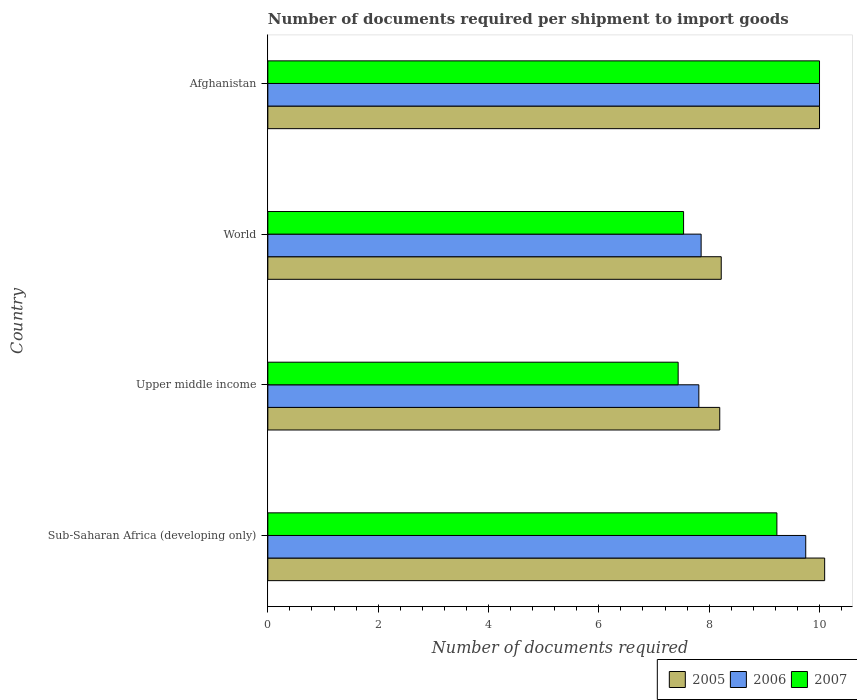Are the number of bars per tick equal to the number of legend labels?
Offer a terse response. Yes. Are the number of bars on each tick of the Y-axis equal?
Provide a short and direct response. Yes. How many bars are there on the 1st tick from the bottom?
Give a very brief answer. 3. What is the label of the 2nd group of bars from the top?
Keep it short and to the point. World. What is the number of documents required per shipment to import goods in 2007 in World?
Keep it short and to the point. 7.54. Across all countries, what is the maximum number of documents required per shipment to import goods in 2006?
Offer a very short reply. 10. Across all countries, what is the minimum number of documents required per shipment to import goods in 2006?
Provide a short and direct response. 7.81. In which country was the number of documents required per shipment to import goods in 2007 maximum?
Your response must be concise. Afghanistan. In which country was the number of documents required per shipment to import goods in 2005 minimum?
Make the answer very short. Upper middle income. What is the total number of documents required per shipment to import goods in 2007 in the graph?
Offer a very short reply. 34.2. What is the difference between the number of documents required per shipment to import goods in 2005 in Upper middle income and that in World?
Ensure brevity in your answer.  -0.03. What is the difference between the number of documents required per shipment to import goods in 2005 in Upper middle income and the number of documents required per shipment to import goods in 2007 in Afghanistan?
Keep it short and to the point. -1.81. What is the average number of documents required per shipment to import goods in 2006 per country?
Ensure brevity in your answer.  8.85. What is the difference between the number of documents required per shipment to import goods in 2007 and number of documents required per shipment to import goods in 2005 in Sub-Saharan Africa (developing only)?
Give a very brief answer. -0.87. What is the ratio of the number of documents required per shipment to import goods in 2007 in Sub-Saharan Africa (developing only) to that in World?
Your response must be concise. 1.22. What is the difference between the highest and the lowest number of documents required per shipment to import goods in 2006?
Offer a terse response. 2.19. What does the 1st bar from the bottom in Afghanistan represents?
Give a very brief answer. 2005. Is it the case that in every country, the sum of the number of documents required per shipment to import goods in 2005 and number of documents required per shipment to import goods in 2007 is greater than the number of documents required per shipment to import goods in 2006?
Offer a very short reply. Yes. How many bars are there?
Provide a succinct answer. 12. What is the difference between two consecutive major ticks on the X-axis?
Make the answer very short. 2. Are the values on the major ticks of X-axis written in scientific E-notation?
Offer a terse response. No. Does the graph contain any zero values?
Offer a very short reply. No. Where does the legend appear in the graph?
Keep it short and to the point. Bottom right. How many legend labels are there?
Offer a very short reply. 3. How are the legend labels stacked?
Offer a terse response. Horizontal. What is the title of the graph?
Keep it short and to the point. Number of documents required per shipment to import goods. Does "1963" appear as one of the legend labels in the graph?
Your answer should be compact. No. What is the label or title of the X-axis?
Give a very brief answer. Number of documents required. What is the label or title of the Y-axis?
Your response must be concise. Country. What is the Number of documents required of 2005 in Sub-Saharan Africa (developing only)?
Ensure brevity in your answer.  10.09. What is the Number of documents required in 2006 in Sub-Saharan Africa (developing only)?
Your answer should be very brief. 9.75. What is the Number of documents required in 2007 in Sub-Saharan Africa (developing only)?
Make the answer very short. 9.23. What is the Number of documents required in 2005 in Upper middle income?
Your answer should be compact. 8.19. What is the Number of documents required in 2006 in Upper middle income?
Offer a very short reply. 7.81. What is the Number of documents required of 2007 in Upper middle income?
Give a very brief answer. 7.44. What is the Number of documents required in 2005 in World?
Keep it short and to the point. 8.22. What is the Number of documents required in 2006 in World?
Give a very brief answer. 7.85. What is the Number of documents required of 2007 in World?
Ensure brevity in your answer.  7.54. What is the Number of documents required in 2005 in Afghanistan?
Your response must be concise. 10. What is the Number of documents required of 2007 in Afghanistan?
Give a very brief answer. 10. Across all countries, what is the maximum Number of documents required in 2005?
Your answer should be very brief. 10.09. Across all countries, what is the minimum Number of documents required in 2005?
Make the answer very short. 8.19. Across all countries, what is the minimum Number of documents required in 2006?
Give a very brief answer. 7.81. Across all countries, what is the minimum Number of documents required in 2007?
Give a very brief answer. 7.44. What is the total Number of documents required in 2005 in the graph?
Make the answer very short. 36.5. What is the total Number of documents required in 2006 in the graph?
Your answer should be compact. 35.42. What is the total Number of documents required in 2007 in the graph?
Your answer should be compact. 34.2. What is the difference between the Number of documents required of 2005 in Sub-Saharan Africa (developing only) and that in Upper middle income?
Ensure brevity in your answer.  1.9. What is the difference between the Number of documents required in 2006 in Sub-Saharan Africa (developing only) and that in Upper middle income?
Your answer should be very brief. 1.94. What is the difference between the Number of documents required of 2007 in Sub-Saharan Africa (developing only) and that in Upper middle income?
Your response must be concise. 1.79. What is the difference between the Number of documents required of 2005 in Sub-Saharan Africa (developing only) and that in World?
Ensure brevity in your answer.  1.87. What is the difference between the Number of documents required of 2006 in Sub-Saharan Africa (developing only) and that in World?
Your answer should be very brief. 1.9. What is the difference between the Number of documents required in 2007 in Sub-Saharan Africa (developing only) and that in World?
Keep it short and to the point. 1.69. What is the difference between the Number of documents required in 2005 in Sub-Saharan Africa (developing only) and that in Afghanistan?
Your answer should be compact. 0.09. What is the difference between the Number of documents required in 2007 in Sub-Saharan Africa (developing only) and that in Afghanistan?
Your response must be concise. -0.77. What is the difference between the Number of documents required in 2005 in Upper middle income and that in World?
Keep it short and to the point. -0.03. What is the difference between the Number of documents required of 2006 in Upper middle income and that in World?
Ensure brevity in your answer.  -0.04. What is the difference between the Number of documents required of 2007 in Upper middle income and that in World?
Your response must be concise. -0.1. What is the difference between the Number of documents required in 2005 in Upper middle income and that in Afghanistan?
Give a very brief answer. -1.81. What is the difference between the Number of documents required in 2006 in Upper middle income and that in Afghanistan?
Provide a succinct answer. -2.19. What is the difference between the Number of documents required in 2007 in Upper middle income and that in Afghanistan?
Ensure brevity in your answer.  -2.56. What is the difference between the Number of documents required of 2005 in World and that in Afghanistan?
Keep it short and to the point. -1.78. What is the difference between the Number of documents required of 2006 in World and that in Afghanistan?
Provide a short and direct response. -2.15. What is the difference between the Number of documents required in 2007 in World and that in Afghanistan?
Offer a very short reply. -2.46. What is the difference between the Number of documents required of 2005 in Sub-Saharan Africa (developing only) and the Number of documents required of 2006 in Upper middle income?
Provide a succinct answer. 2.28. What is the difference between the Number of documents required of 2005 in Sub-Saharan Africa (developing only) and the Number of documents required of 2007 in Upper middle income?
Your answer should be compact. 2.66. What is the difference between the Number of documents required in 2006 in Sub-Saharan Africa (developing only) and the Number of documents required in 2007 in Upper middle income?
Offer a very short reply. 2.31. What is the difference between the Number of documents required in 2005 in Sub-Saharan Africa (developing only) and the Number of documents required in 2006 in World?
Offer a terse response. 2.24. What is the difference between the Number of documents required in 2005 in Sub-Saharan Africa (developing only) and the Number of documents required in 2007 in World?
Provide a succinct answer. 2.56. What is the difference between the Number of documents required of 2006 in Sub-Saharan Africa (developing only) and the Number of documents required of 2007 in World?
Provide a succinct answer. 2.21. What is the difference between the Number of documents required in 2005 in Sub-Saharan Africa (developing only) and the Number of documents required in 2006 in Afghanistan?
Give a very brief answer. 0.09. What is the difference between the Number of documents required in 2005 in Sub-Saharan Africa (developing only) and the Number of documents required in 2007 in Afghanistan?
Offer a terse response. 0.09. What is the difference between the Number of documents required of 2005 in Upper middle income and the Number of documents required of 2006 in World?
Offer a terse response. 0.34. What is the difference between the Number of documents required in 2005 in Upper middle income and the Number of documents required in 2007 in World?
Ensure brevity in your answer.  0.66. What is the difference between the Number of documents required of 2006 in Upper middle income and the Number of documents required of 2007 in World?
Provide a short and direct response. 0.28. What is the difference between the Number of documents required in 2005 in Upper middle income and the Number of documents required in 2006 in Afghanistan?
Provide a short and direct response. -1.81. What is the difference between the Number of documents required of 2005 in Upper middle income and the Number of documents required of 2007 in Afghanistan?
Make the answer very short. -1.81. What is the difference between the Number of documents required in 2006 in Upper middle income and the Number of documents required in 2007 in Afghanistan?
Give a very brief answer. -2.19. What is the difference between the Number of documents required in 2005 in World and the Number of documents required in 2006 in Afghanistan?
Keep it short and to the point. -1.78. What is the difference between the Number of documents required in 2005 in World and the Number of documents required in 2007 in Afghanistan?
Your response must be concise. -1.78. What is the difference between the Number of documents required in 2006 in World and the Number of documents required in 2007 in Afghanistan?
Keep it short and to the point. -2.15. What is the average Number of documents required in 2005 per country?
Offer a terse response. 9.13. What is the average Number of documents required in 2006 per country?
Your answer should be very brief. 8.85. What is the average Number of documents required in 2007 per country?
Your response must be concise. 8.55. What is the difference between the Number of documents required of 2005 and Number of documents required of 2006 in Sub-Saharan Africa (developing only)?
Ensure brevity in your answer.  0.34. What is the difference between the Number of documents required of 2005 and Number of documents required of 2007 in Sub-Saharan Africa (developing only)?
Make the answer very short. 0.87. What is the difference between the Number of documents required of 2006 and Number of documents required of 2007 in Sub-Saharan Africa (developing only)?
Make the answer very short. 0.52. What is the difference between the Number of documents required in 2005 and Number of documents required in 2006 in Upper middle income?
Make the answer very short. 0.38. What is the difference between the Number of documents required in 2005 and Number of documents required in 2007 in Upper middle income?
Provide a succinct answer. 0.75. What is the difference between the Number of documents required of 2005 and Number of documents required of 2006 in World?
Your answer should be very brief. 0.36. What is the difference between the Number of documents required in 2005 and Number of documents required in 2007 in World?
Make the answer very short. 0.68. What is the difference between the Number of documents required of 2006 and Number of documents required of 2007 in World?
Make the answer very short. 0.32. What is the difference between the Number of documents required of 2005 and Number of documents required of 2006 in Afghanistan?
Your answer should be very brief. 0. What is the difference between the Number of documents required of 2005 and Number of documents required of 2007 in Afghanistan?
Keep it short and to the point. 0. What is the ratio of the Number of documents required of 2005 in Sub-Saharan Africa (developing only) to that in Upper middle income?
Provide a short and direct response. 1.23. What is the ratio of the Number of documents required of 2006 in Sub-Saharan Africa (developing only) to that in Upper middle income?
Provide a short and direct response. 1.25. What is the ratio of the Number of documents required in 2007 in Sub-Saharan Africa (developing only) to that in Upper middle income?
Keep it short and to the point. 1.24. What is the ratio of the Number of documents required in 2005 in Sub-Saharan Africa (developing only) to that in World?
Keep it short and to the point. 1.23. What is the ratio of the Number of documents required in 2006 in Sub-Saharan Africa (developing only) to that in World?
Your answer should be compact. 1.24. What is the ratio of the Number of documents required in 2007 in Sub-Saharan Africa (developing only) to that in World?
Offer a terse response. 1.22. What is the ratio of the Number of documents required of 2005 in Sub-Saharan Africa (developing only) to that in Afghanistan?
Offer a terse response. 1.01. What is the ratio of the Number of documents required in 2006 in Sub-Saharan Africa (developing only) to that in Afghanistan?
Offer a very short reply. 0.97. What is the ratio of the Number of documents required in 2007 in Sub-Saharan Africa (developing only) to that in Afghanistan?
Keep it short and to the point. 0.92. What is the ratio of the Number of documents required of 2005 in Upper middle income to that in World?
Your response must be concise. 1. What is the ratio of the Number of documents required of 2007 in Upper middle income to that in World?
Your response must be concise. 0.99. What is the ratio of the Number of documents required in 2005 in Upper middle income to that in Afghanistan?
Offer a terse response. 0.82. What is the ratio of the Number of documents required of 2006 in Upper middle income to that in Afghanistan?
Your answer should be very brief. 0.78. What is the ratio of the Number of documents required of 2007 in Upper middle income to that in Afghanistan?
Give a very brief answer. 0.74. What is the ratio of the Number of documents required of 2005 in World to that in Afghanistan?
Offer a very short reply. 0.82. What is the ratio of the Number of documents required in 2006 in World to that in Afghanistan?
Provide a succinct answer. 0.79. What is the ratio of the Number of documents required in 2007 in World to that in Afghanistan?
Your answer should be very brief. 0.75. What is the difference between the highest and the second highest Number of documents required of 2005?
Your answer should be very brief. 0.09. What is the difference between the highest and the second highest Number of documents required of 2006?
Offer a very short reply. 0.25. What is the difference between the highest and the second highest Number of documents required in 2007?
Your answer should be compact. 0.77. What is the difference between the highest and the lowest Number of documents required of 2005?
Offer a terse response. 1.9. What is the difference between the highest and the lowest Number of documents required in 2006?
Make the answer very short. 2.19. What is the difference between the highest and the lowest Number of documents required of 2007?
Your response must be concise. 2.56. 